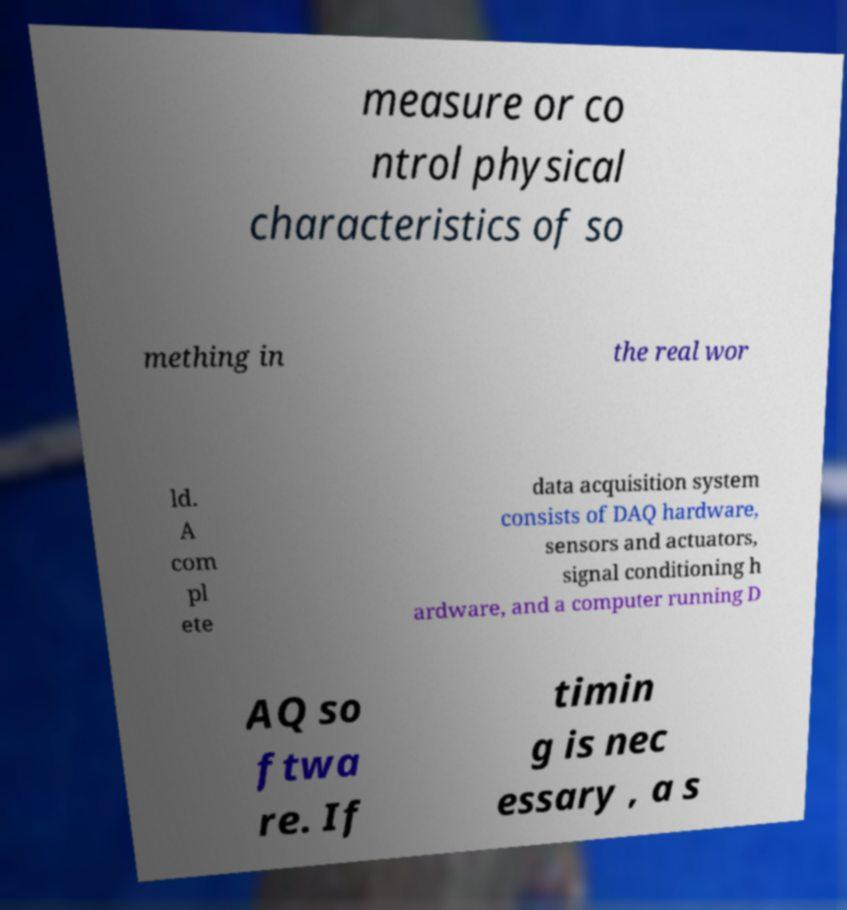I need the written content from this picture converted into text. Can you do that? measure or co ntrol physical characteristics of so mething in the real wor ld. A com pl ete data acquisition system consists of DAQ hardware, sensors and actuators, signal conditioning h ardware, and a computer running D AQ so ftwa re. If timin g is nec essary , a s 